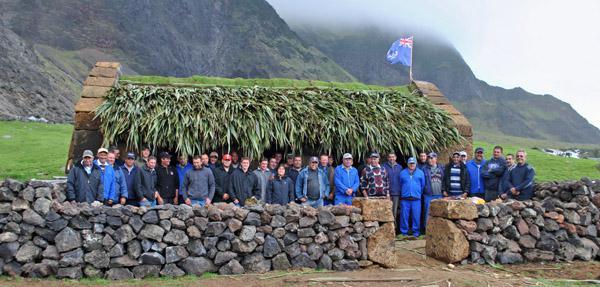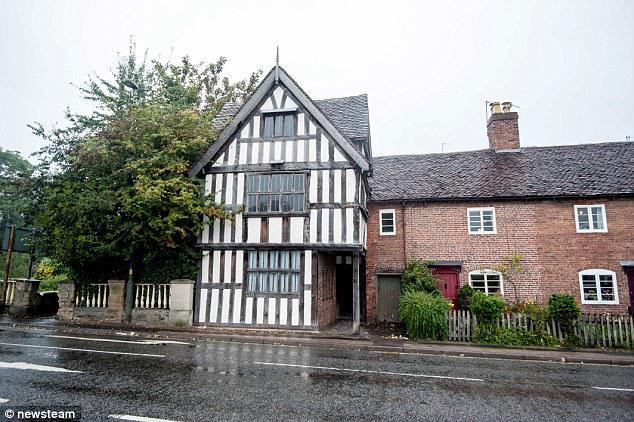The first image is the image on the left, the second image is the image on the right. Considering the images on both sides, is "People are standing in front of one of the buildings." valid? Answer yes or no. Yes. The first image is the image on the left, the second image is the image on the right. Given the left and right images, does the statement "In at least one image, there are at least two homes with white walls." hold true? Answer yes or no. No. 